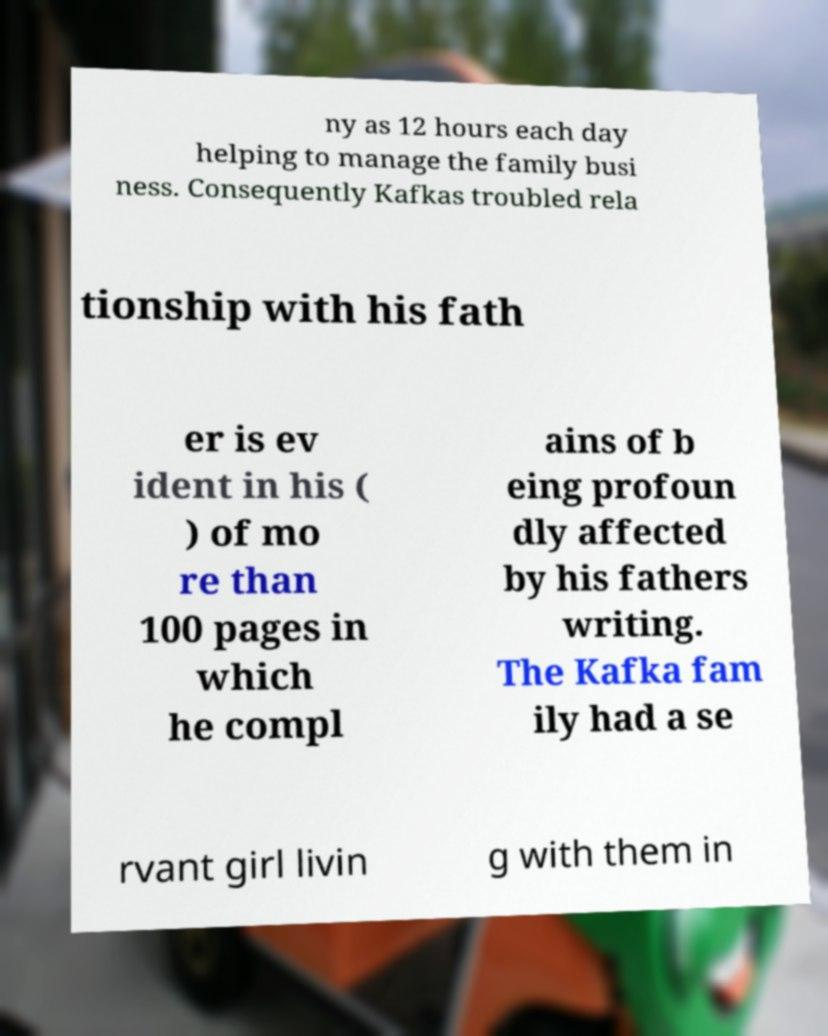Could you assist in decoding the text presented in this image and type it out clearly? ny as 12 hours each day helping to manage the family busi ness. Consequently Kafkas troubled rela tionship with his fath er is ev ident in his ( ) of mo re than 100 pages in which he compl ains of b eing profoun dly affected by his fathers writing. The Kafka fam ily had a se rvant girl livin g with them in 